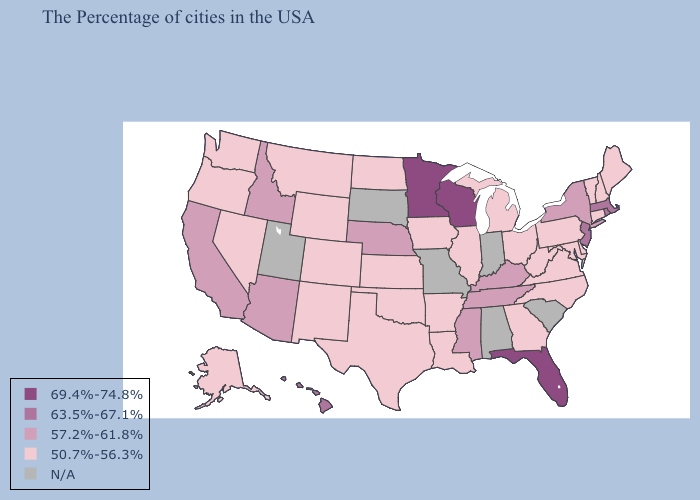Does Massachusetts have the lowest value in the USA?
Answer briefly. No. Among the states that border Montana , does North Dakota have the highest value?
Answer briefly. No. Which states have the lowest value in the South?
Give a very brief answer. Delaware, Maryland, Virginia, North Carolina, West Virginia, Georgia, Louisiana, Arkansas, Oklahoma, Texas. Does the first symbol in the legend represent the smallest category?
Short answer required. No. What is the value of Arkansas?
Keep it brief. 50.7%-56.3%. Does Pennsylvania have the highest value in the Northeast?
Answer briefly. No. What is the highest value in the USA?
Answer briefly. 69.4%-74.8%. What is the lowest value in the USA?
Give a very brief answer. 50.7%-56.3%. Which states hav the highest value in the MidWest?
Keep it brief. Wisconsin, Minnesota. Which states hav the highest value in the South?
Quick response, please. Florida. What is the value of Nevada?
Be succinct. 50.7%-56.3%. Which states have the highest value in the USA?
Keep it brief. Florida, Wisconsin, Minnesota. Is the legend a continuous bar?
Give a very brief answer. No. Which states have the lowest value in the MidWest?
Write a very short answer. Ohio, Michigan, Illinois, Iowa, Kansas, North Dakota. 